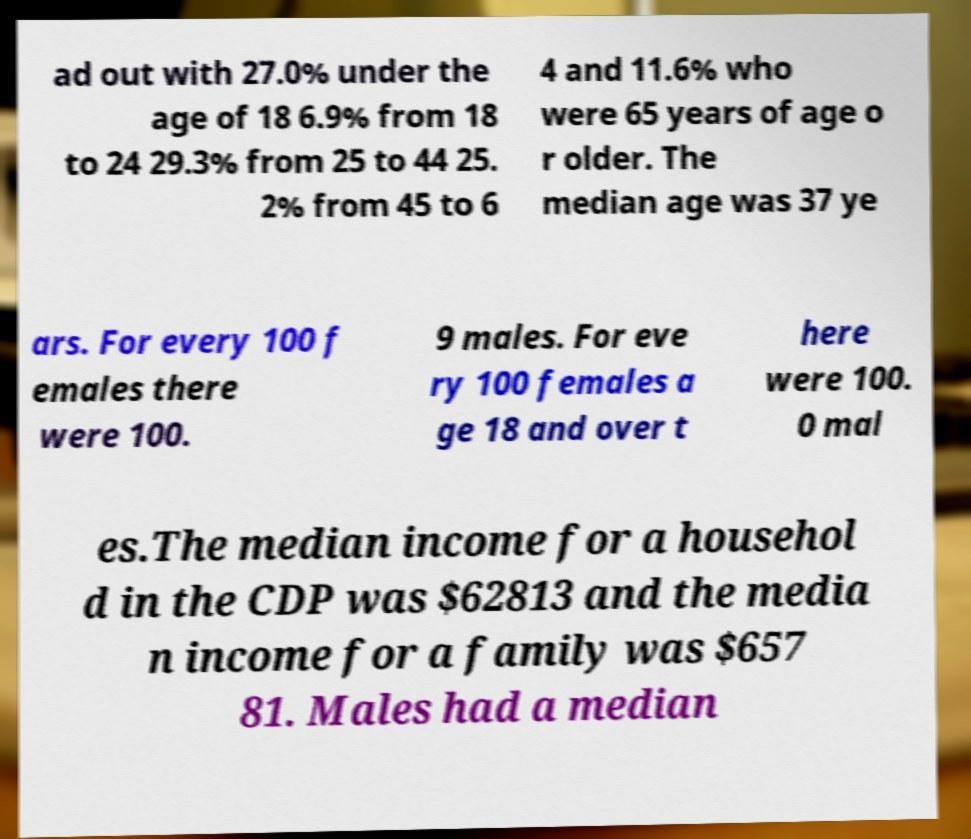Please identify and transcribe the text found in this image. ad out with 27.0% under the age of 18 6.9% from 18 to 24 29.3% from 25 to 44 25. 2% from 45 to 6 4 and 11.6% who were 65 years of age o r older. The median age was 37 ye ars. For every 100 f emales there were 100. 9 males. For eve ry 100 females a ge 18 and over t here were 100. 0 mal es.The median income for a househol d in the CDP was $62813 and the media n income for a family was $657 81. Males had a median 